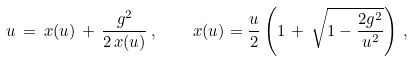Convert formula to latex. <formula><loc_0><loc_0><loc_500><loc_500>u \, = \, x ( u ) \, + \, \frac { g ^ { 2 } } { 2 \, x ( u ) } \, , \quad x ( u ) = \frac { u } { 2 } \left ( 1 \, + \, \sqrt { 1 - \frac { 2 g ^ { 2 } } { u ^ { 2 } } } \right ) \, ,</formula> 